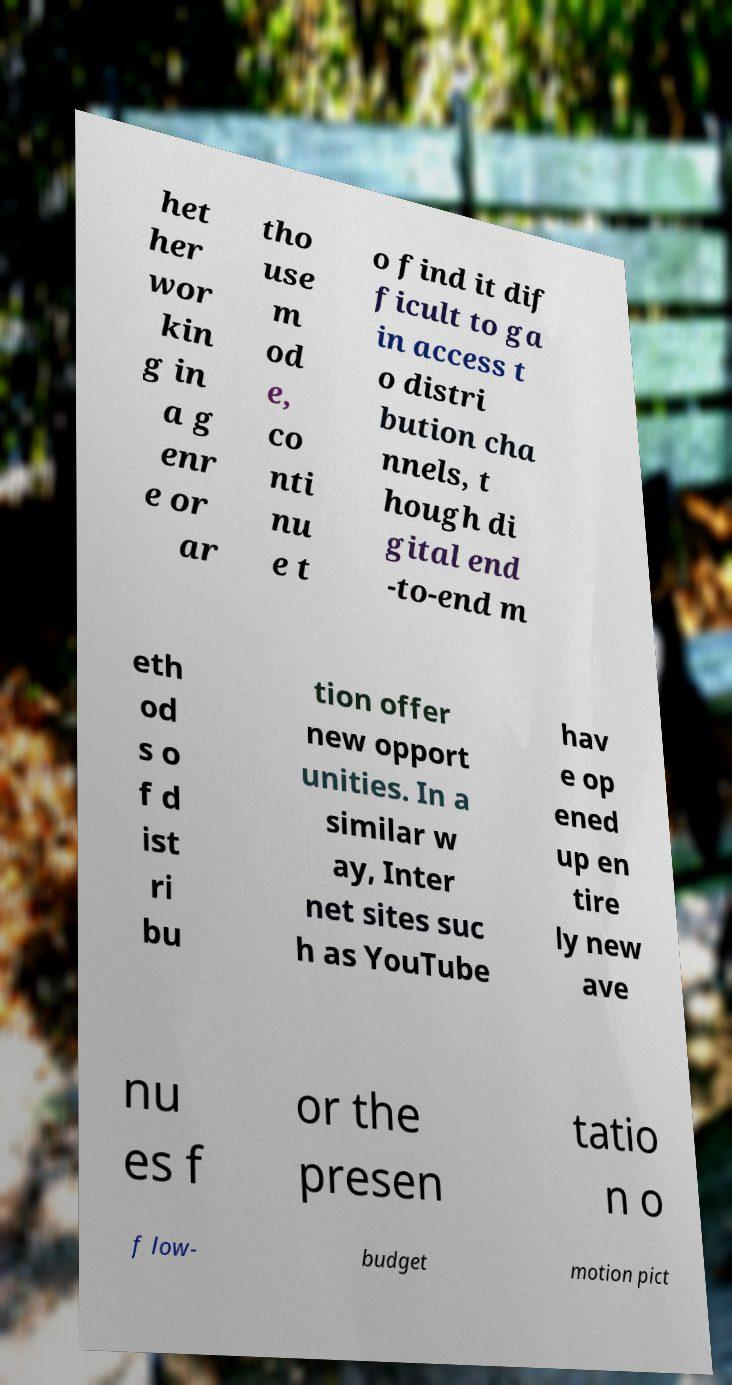I need the written content from this picture converted into text. Can you do that? het her wor kin g in a g enr e or ar tho use m od e, co nti nu e t o find it dif ficult to ga in access t o distri bution cha nnels, t hough di gital end -to-end m eth od s o f d ist ri bu tion offer new opport unities. In a similar w ay, Inter net sites suc h as YouTube hav e op ened up en tire ly new ave nu es f or the presen tatio n o f low- budget motion pict 